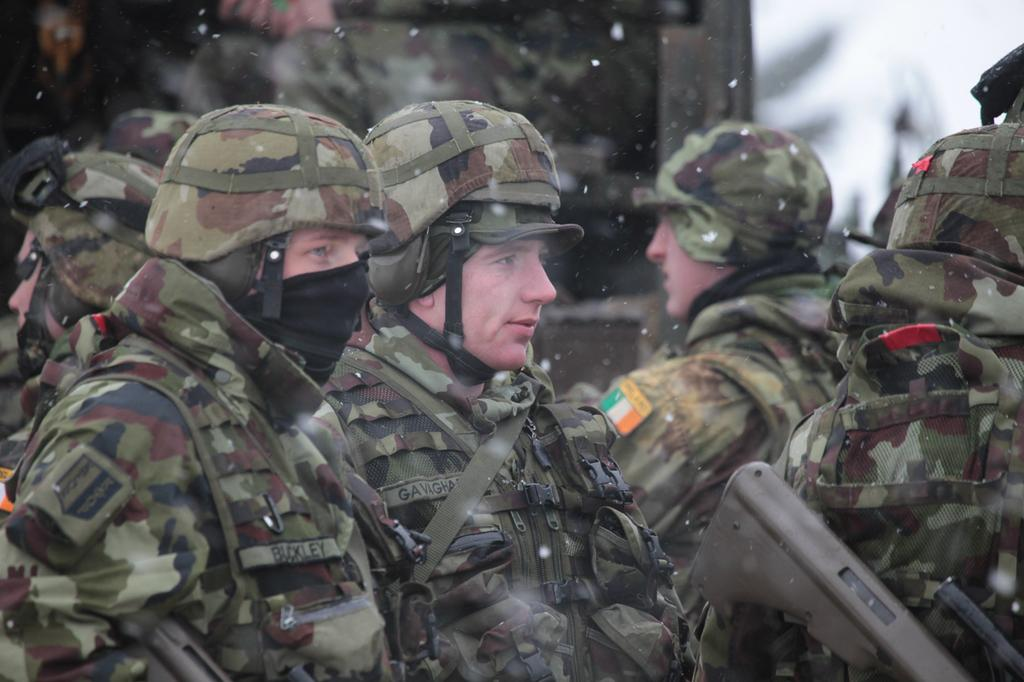How many people are in the group that is visible in the image? There is a group of people in the image, but the exact number is not specified. What are some people in the group wearing? Some people in the group are wearing caps. What object can be seen in the image that is typically associated with violence? There is a gun visible in the image. Can you describe the background of the image? The background of the image is blurry. What type of banana is being used to crack open the safe in the image? There is no banana or safe present in the image; it features a group of people and a gun. How does the group of people stop the gun from being used in the image? The image does not depict any action to stop the gun from being used; it simply shows the presence of a gun. 